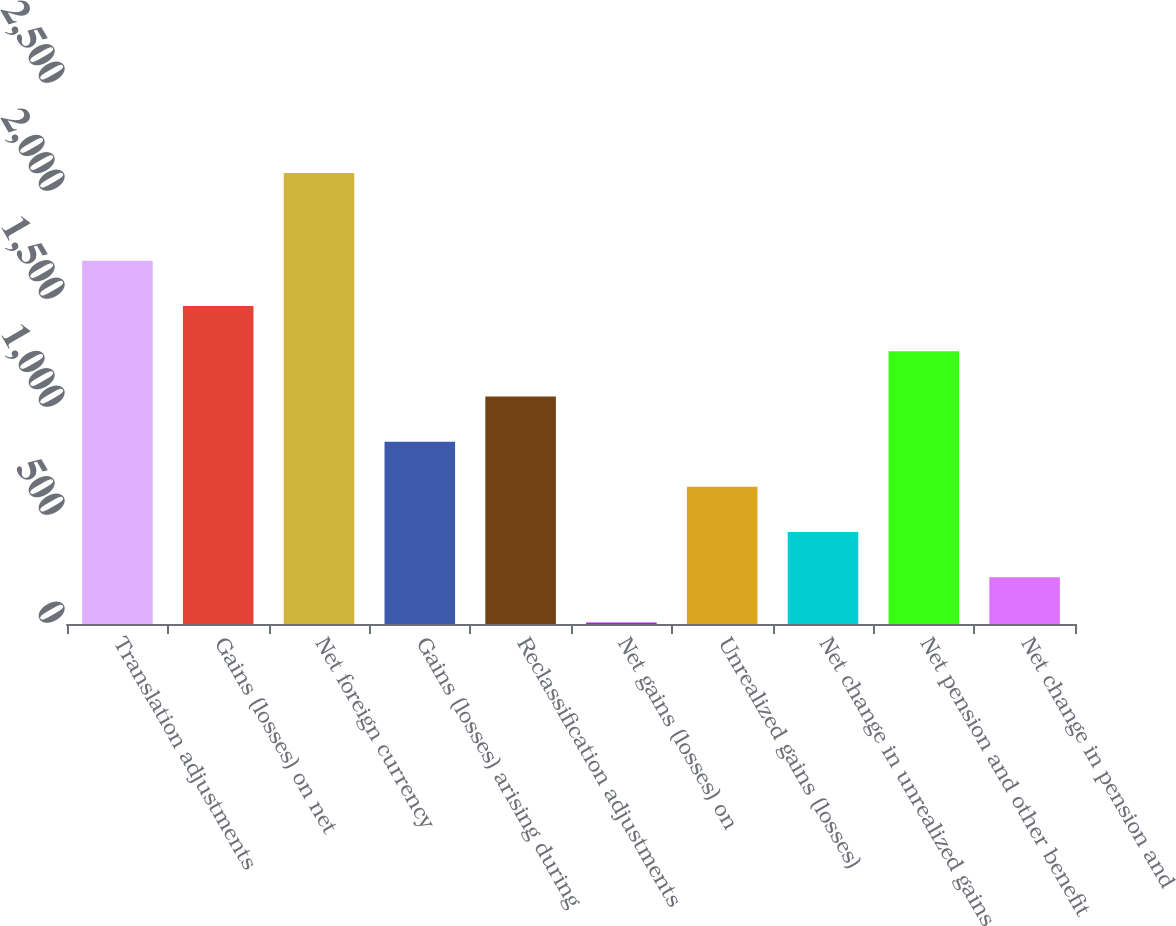<chart> <loc_0><loc_0><loc_500><loc_500><bar_chart><fcel>Translation adjustments<fcel>Gains (losses) on net<fcel>Net foreign currency<fcel>Gains (losses) arising during<fcel>Reclassification adjustments<fcel>Net gains (losses) on<fcel>Unrealized gains (losses)<fcel>Net change in unrealized gains<fcel>Net pension and other benefit<fcel>Net change in pension and<nl><fcel>1681.4<fcel>1472.1<fcel>2088<fcel>844.2<fcel>1053.5<fcel>7<fcel>634.9<fcel>425.6<fcel>1262.8<fcel>216.3<nl></chart> 